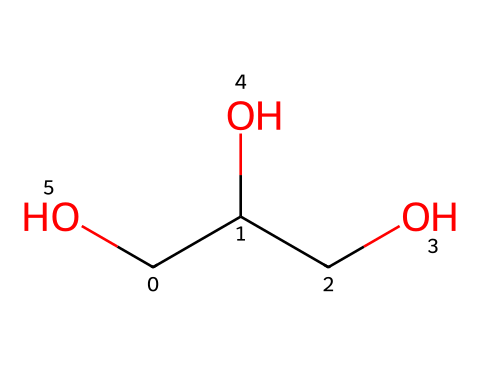What is the common name of the chemical represented by this structure? The compound represented by the SMILES is glycerin, which is commonly used as a moisturizing agent in cosmetics.
Answer: glycerin How many carbon atoms are in the structure? By analyzing the SMILES notation, we count three carbon atoms represented by "C" in the main chain and branching, indicating there are three carbon atoms total.
Answer: three How many hydroxyl (–OH) groups are present in the chemical? The SMILES notation displays two "O" connected to "C", indicating there are two hydroxyl groups present in the structure.
Answer: two Is this chemical hydrophilic or hydrophobic? Considering the presence of hydroxyl groups and their ability to form hydrogen bonds with water, glycerin is hydrophilic.
Answer: hydrophilic What molecular feature allows glycerin to act as a moisturizer? The presence of hydroxyl groups allows glycerin to attract and retain moisture from the environment, making it effective as a moisturizer.
Answer: hydroxyl groups 